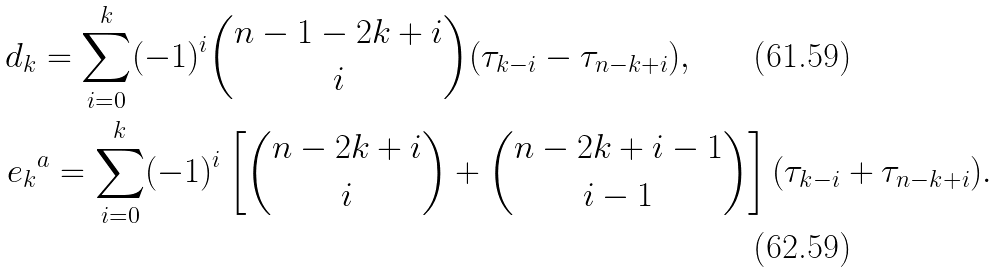<formula> <loc_0><loc_0><loc_500><loc_500>d _ { k } & = \sum _ { i = 0 } ^ { k } ( - 1 ) ^ { i } \binom { n - 1 - 2 k + i } { i } ( \tau _ { k - i } - \tau _ { n - k + i } ) , \\ e _ { k } & ^ { a } = \sum _ { i = 0 } ^ { k } ( - 1 ) ^ { i } \left [ \binom { n - 2 k + i } { i } + \binom { n - 2 k + i - 1 } { i - 1 } \right ] ( \tau _ { k - i } + \tau _ { n - k + i } ) .</formula> 